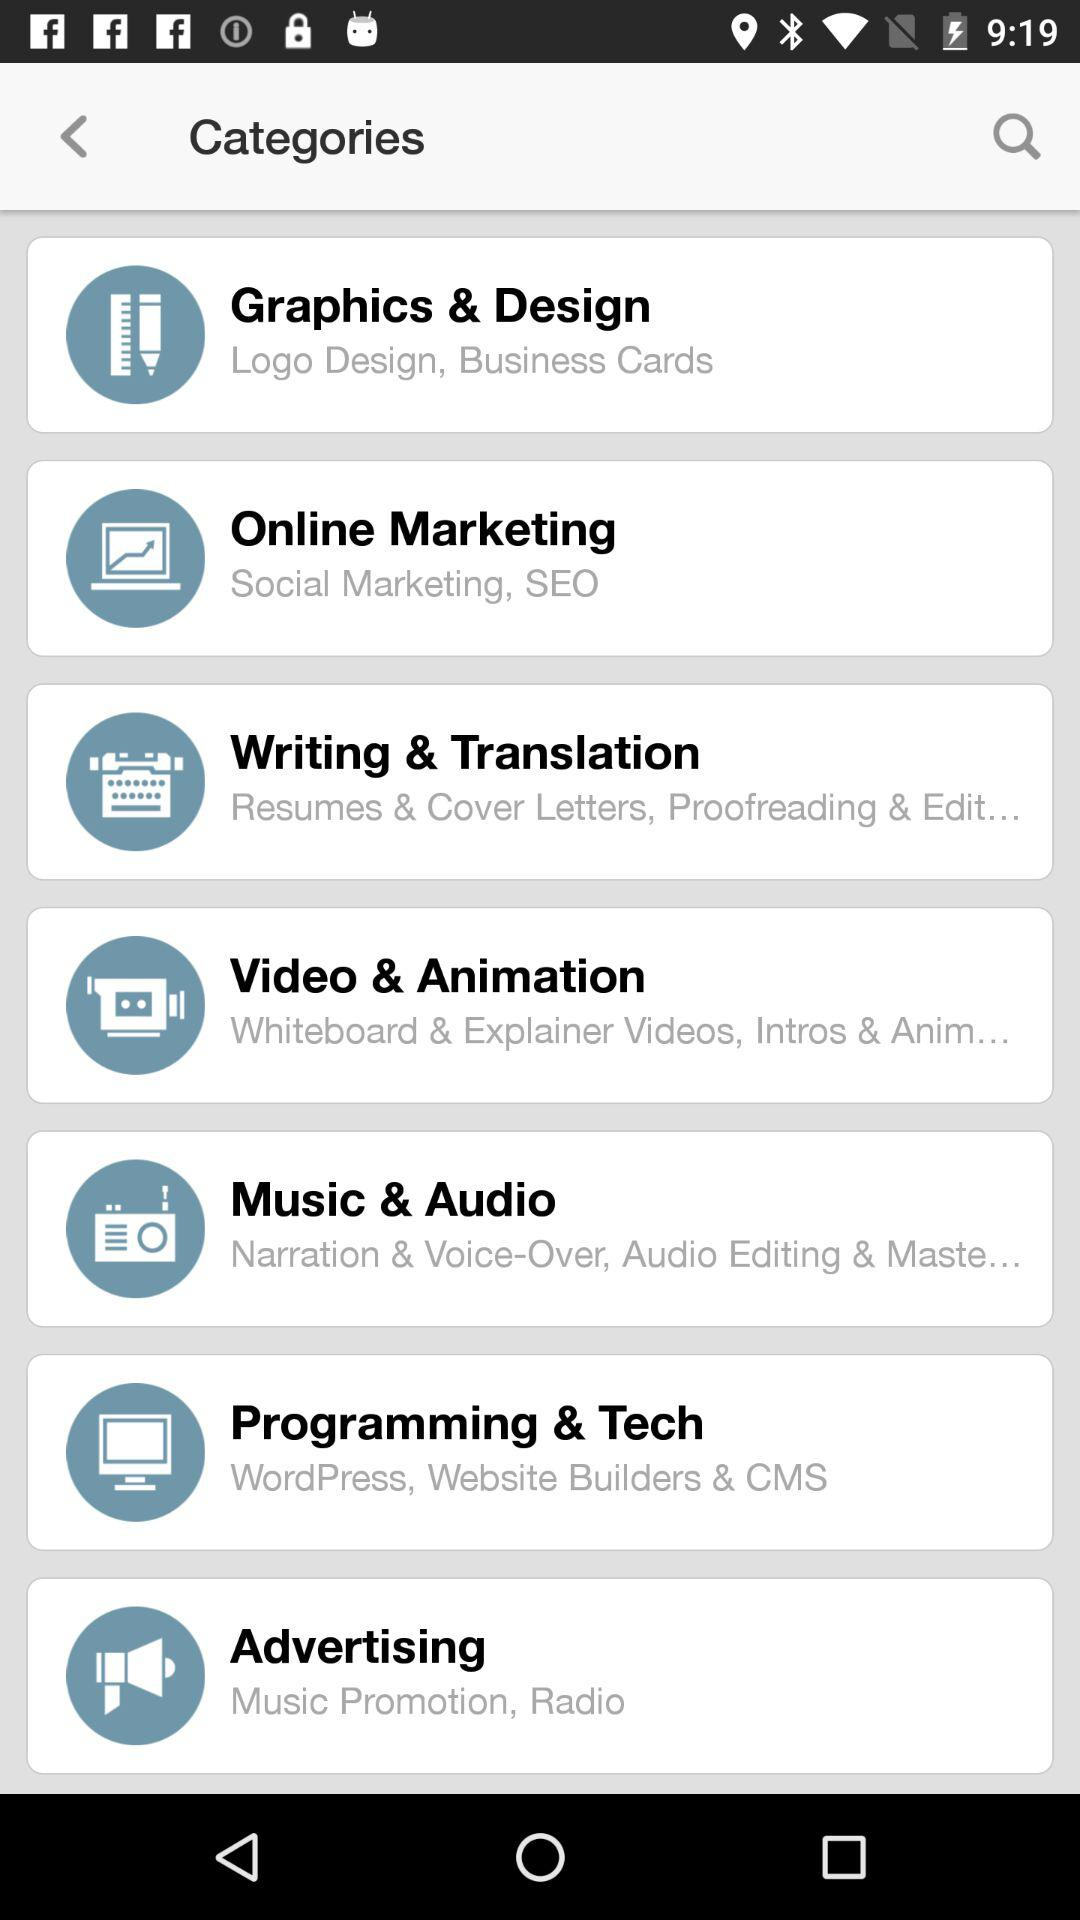What does Video & Animation entail?
Answer the question using a single word or phrase. Video & Animation entail "Whiteboard & Explainer Videos, Intros & Anim..." 